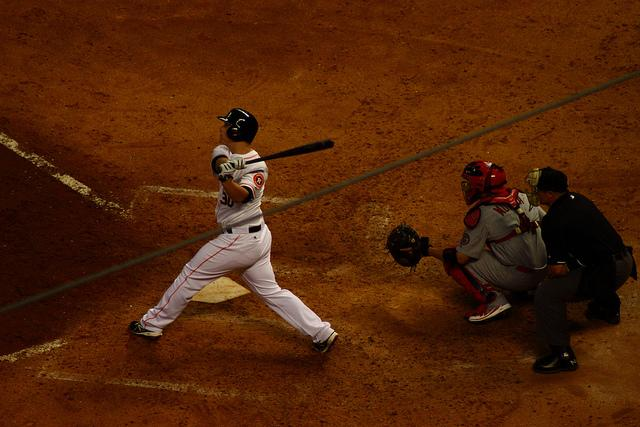What are the team colors for the team playing at pitch?

Choices:
A) blue
B) purple
C) red
D) yellow red 